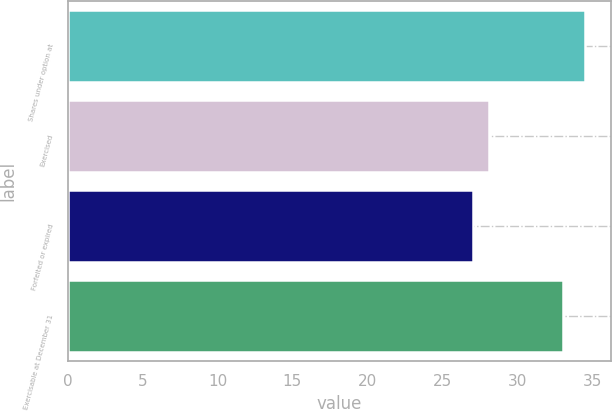<chart> <loc_0><loc_0><loc_500><loc_500><bar_chart><fcel>Shares under option at<fcel>Exercised<fcel>Forfeited or expired<fcel>Exercisable at December 31<nl><fcel>34.53<fcel>28.15<fcel>27.06<fcel>33.07<nl></chart> 